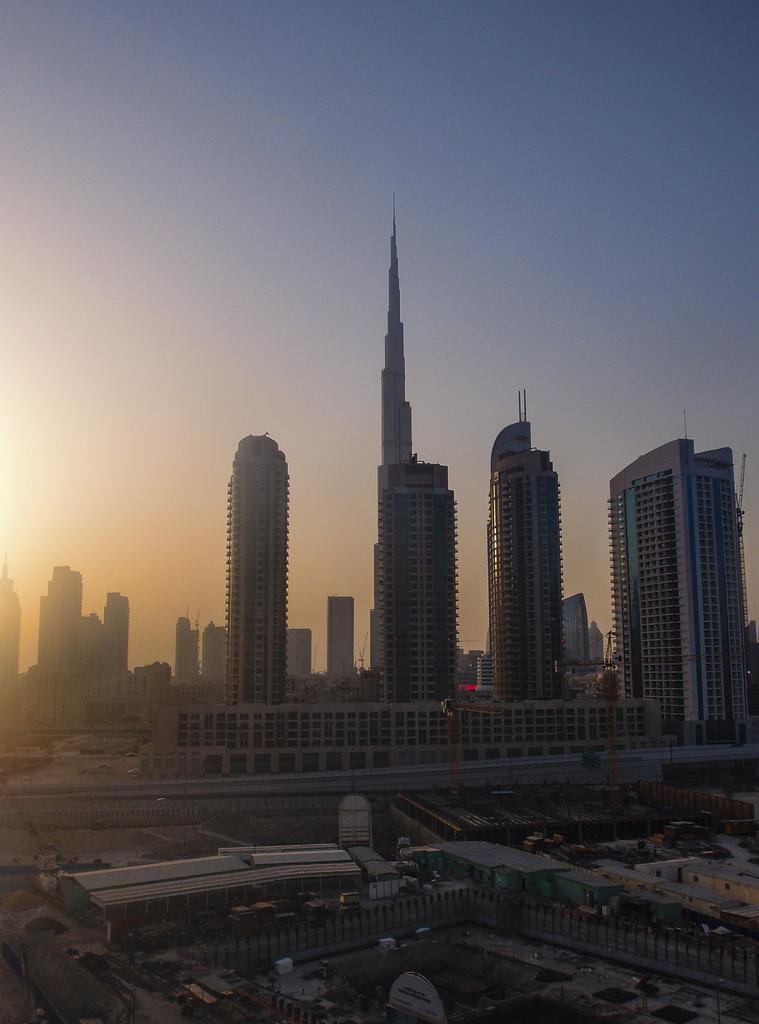What type of view is depicted in the image? The image is an aerial view. What structures can be seen in the image? There are buildings and tower buildings in the image. What type of transportation infrastructure is visible in the image? There is a road visible in the image. What can be seen in the background of the image? The sky is plain and visible in the background of the image. Can you tell me where the doctor is located in the image? There is no doctor present in the image. What type of ocean can be seen in the image? There is no ocean present in the image. 